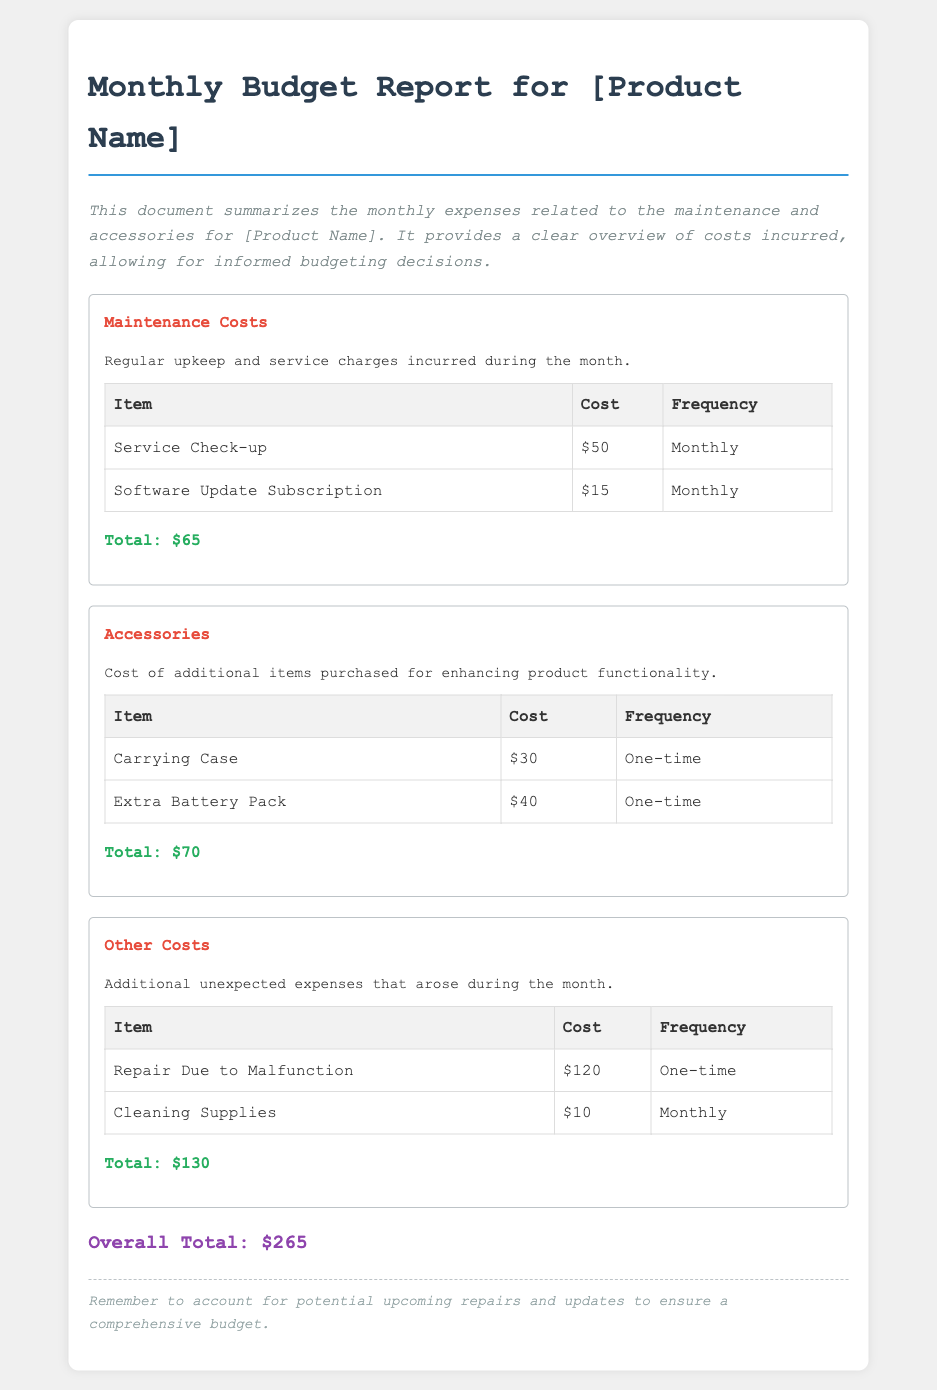what is the total maintenance cost? The total maintenance cost is the sum of all maintenance items listed, which is $50 + $15 = $65.
Answer: $65 how much did the extra battery pack cost? The cost for the extra battery pack is specified in the accessories section.
Answer: $40 what is the cost of the service check-up? The service check-up cost is outlined in the maintenance costs section.
Answer: $50 what is the overall total expenses for the month? The overall total is the sum of all sections: $65 (maintenance) + $70 (accessories) + $130 (other costs) = $265.
Answer: $265 how many one-time purchases are listed? The one-time purchases are explicitly mentioned under the accessories and other costs sections.
Answer: 3 